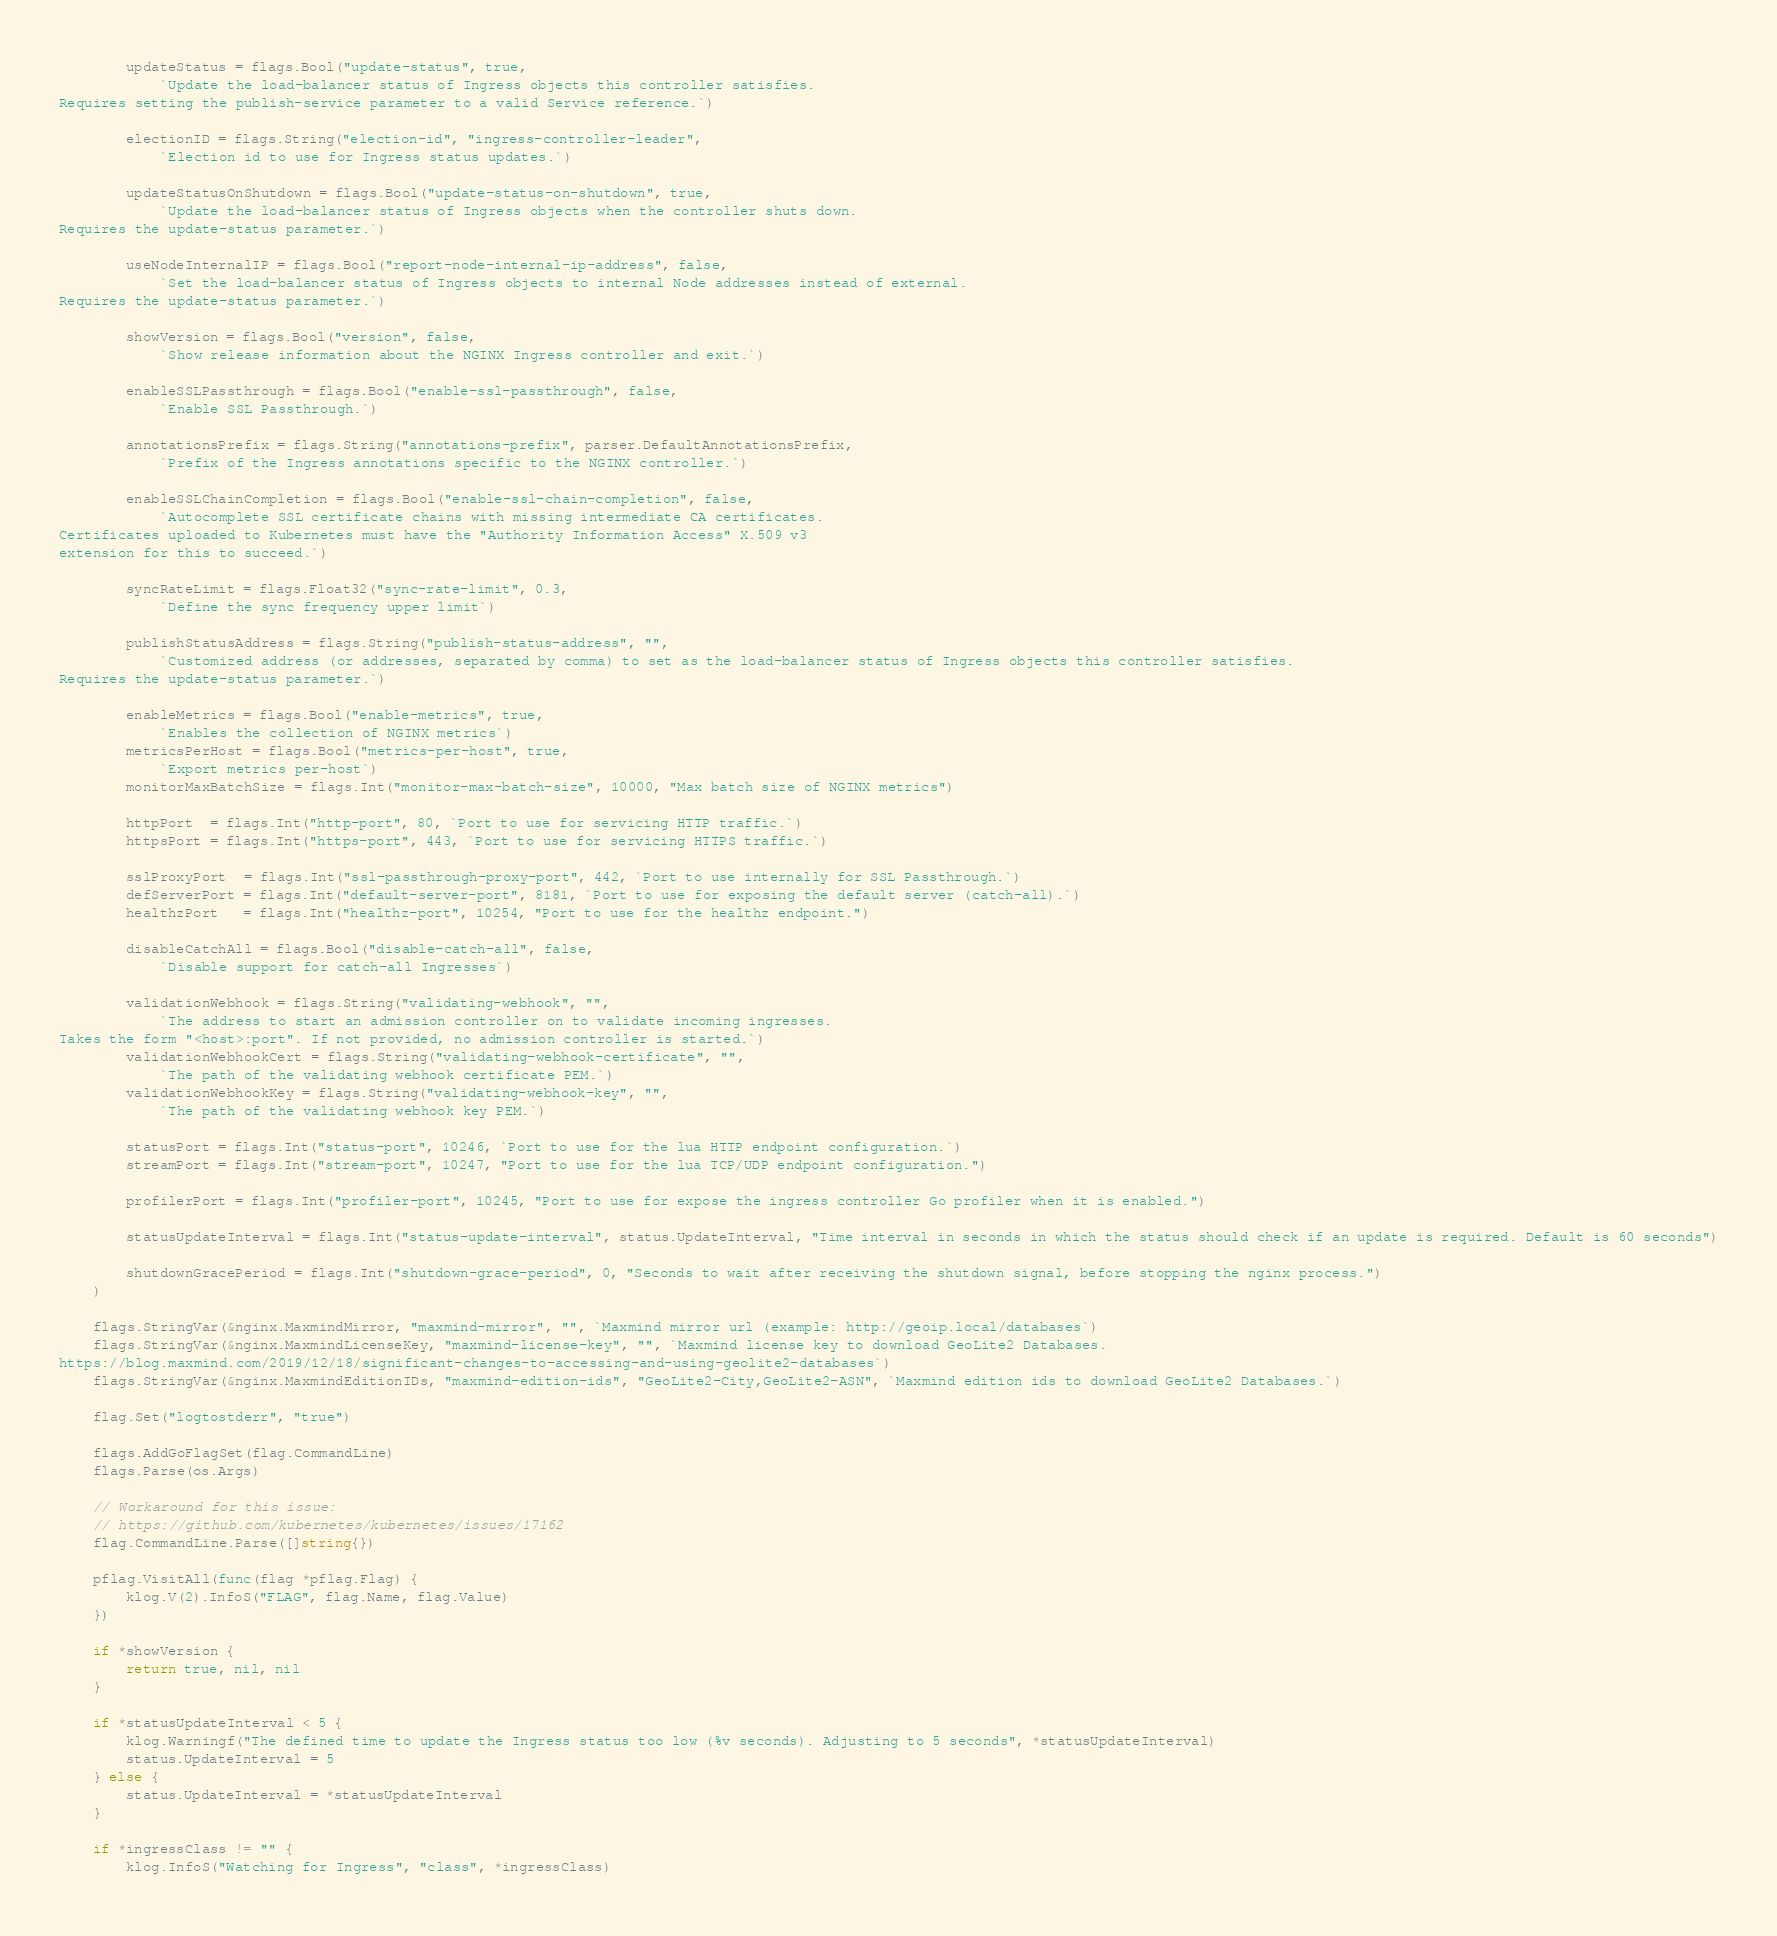Convert code to text. <code><loc_0><loc_0><loc_500><loc_500><_Go_>
		updateStatus = flags.Bool("update-status", true,
			`Update the load-balancer status of Ingress objects this controller satisfies.
Requires setting the publish-service parameter to a valid Service reference.`)

		electionID = flags.String("election-id", "ingress-controller-leader",
			`Election id to use for Ingress status updates.`)

		updateStatusOnShutdown = flags.Bool("update-status-on-shutdown", true,
			`Update the load-balancer status of Ingress objects when the controller shuts down.
Requires the update-status parameter.`)

		useNodeInternalIP = flags.Bool("report-node-internal-ip-address", false,
			`Set the load-balancer status of Ingress objects to internal Node addresses instead of external.
Requires the update-status parameter.`)

		showVersion = flags.Bool("version", false,
			`Show release information about the NGINX Ingress controller and exit.`)

		enableSSLPassthrough = flags.Bool("enable-ssl-passthrough", false,
			`Enable SSL Passthrough.`)

		annotationsPrefix = flags.String("annotations-prefix", parser.DefaultAnnotationsPrefix,
			`Prefix of the Ingress annotations specific to the NGINX controller.`)

		enableSSLChainCompletion = flags.Bool("enable-ssl-chain-completion", false,
			`Autocomplete SSL certificate chains with missing intermediate CA certificates.
Certificates uploaded to Kubernetes must have the "Authority Information Access" X.509 v3
extension for this to succeed.`)

		syncRateLimit = flags.Float32("sync-rate-limit", 0.3,
			`Define the sync frequency upper limit`)

		publishStatusAddress = flags.String("publish-status-address", "",
			`Customized address (or addresses, separated by comma) to set as the load-balancer status of Ingress objects this controller satisfies.
Requires the update-status parameter.`)

		enableMetrics = flags.Bool("enable-metrics", true,
			`Enables the collection of NGINX metrics`)
		metricsPerHost = flags.Bool("metrics-per-host", true,
			`Export metrics per-host`)
		monitorMaxBatchSize = flags.Int("monitor-max-batch-size", 10000, "Max batch size of NGINX metrics")

		httpPort  = flags.Int("http-port", 80, `Port to use for servicing HTTP traffic.`)
		httpsPort = flags.Int("https-port", 443, `Port to use for servicing HTTPS traffic.`)

		sslProxyPort  = flags.Int("ssl-passthrough-proxy-port", 442, `Port to use internally for SSL Passthrough.`)
		defServerPort = flags.Int("default-server-port", 8181, `Port to use for exposing the default server (catch-all).`)
		healthzPort   = flags.Int("healthz-port", 10254, "Port to use for the healthz endpoint.")

		disableCatchAll = flags.Bool("disable-catch-all", false,
			`Disable support for catch-all Ingresses`)

		validationWebhook = flags.String("validating-webhook", "",
			`The address to start an admission controller on to validate incoming ingresses.
Takes the form "<host>:port". If not provided, no admission controller is started.`)
		validationWebhookCert = flags.String("validating-webhook-certificate", "",
			`The path of the validating webhook certificate PEM.`)
		validationWebhookKey = flags.String("validating-webhook-key", "",
			`The path of the validating webhook key PEM.`)

		statusPort = flags.Int("status-port", 10246, `Port to use for the lua HTTP endpoint configuration.`)
		streamPort = flags.Int("stream-port", 10247, "Port to use for the lua TCP/UDP endpoint configuration.")

		profilerPort = flags.Int("profiler-port", 10245, "Port to use for expose the ingress controller Go profiler when it is enabled.")

		statusUpdateInterval = flags.Int("status-update-interval", status.UpdateInterval, "Time interval in seconds in which the status should check if an update is required. Default is 60 seconds")

		shutdownGracePeriod = flags.Int("shutdown-grace-period", 0, "Seconds to wait after receiving the shutdown signal, before stopping the nginx process.")
	)

	flags.StringVar(&nginx.MaxmindMirror, "maxmind-mirror", "", `Maxmind mirror url (example: http://geoip.local/databases`)
	flags.StringVar(&nginx.MaxmindLicenseKey, "maxmind-license-key", "", `Maxmind license key to download GeoLite2 Databases.
https://blog.maxmind.com/2019/12/18/significant-changes-to-accessing-and-using-geolite2-databases`)
	flags.StringVar(&nginx.MaxmindEditionIDs, "maxmind-edition-ids", "GeoLite2-City,GeoLite2-ASN", `Maxmind edition ids to download GeoLite2 Databases.`)

	flag.Set("logtostderr", "true")

	flags.AddGoFlagSet(flag.CommandLine)
	flags.Parse(os.Args)

	// Workaround for this issue:
	// https://github.com/kubernetes/kubernetes/issues/17162
	flag.CommandLine.Parse([]string{})

	pflag.VisitAll(func(flag *pflag.Flag) {
		klog.V(2).InfoS("FLAG", flag.Name, flag.Value)
	})

	if *showVersion {
		return true, nil, nil
	}

	if *statusUpdateInterval < 5 {
		klog.Warningf("The defined time to update the Ingress status too low (%v seconds). Adjusting to 5 seconds", *statusUpdateInterval)
		status.UpdateInterval = 5
	} else {
		status.UpdateInterval = *statusUpdateInterval
	}

	if *ingressClass != "" {
		klog.InfoS("Watching for Ingress", "class", *ingressClass)
</code> 